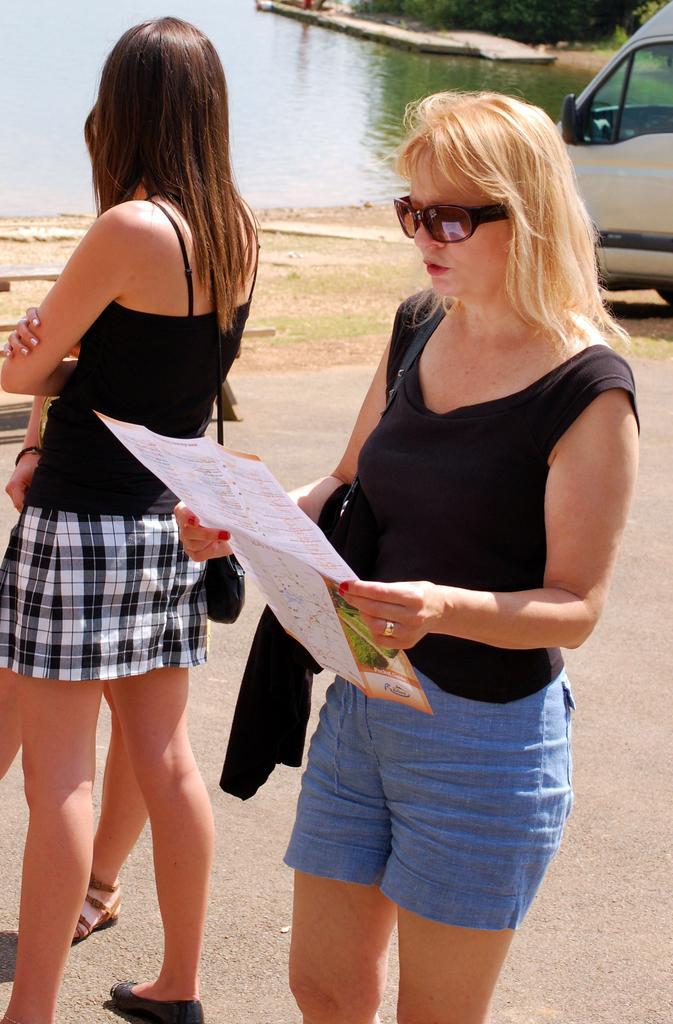Can you describe this image briefly? In the picture I can see people among them the woman on the right side is holding a paper in hands. The woman is wearing shades, black color top, blue color shorts and some other objects. In the background I can see a vehicle on the road, the water and some other objects. 